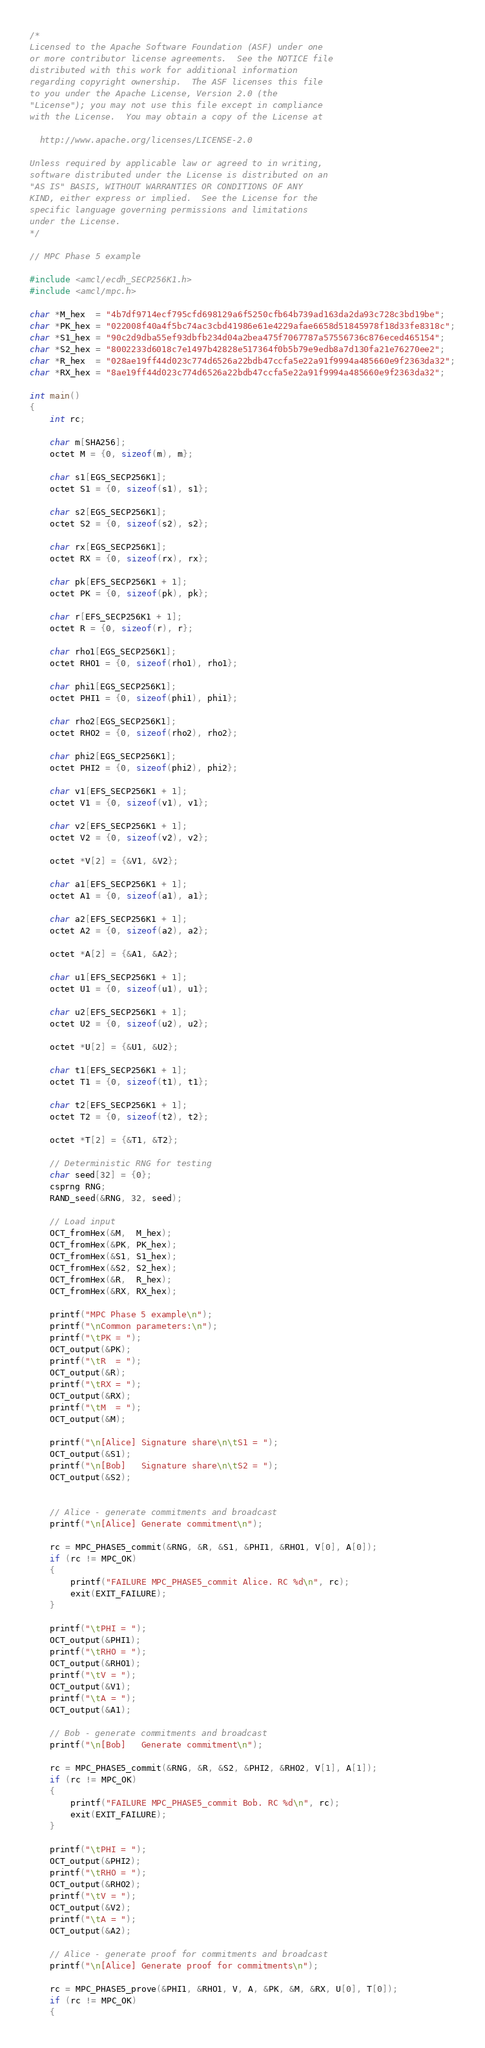<code> <loc_0><loc_0><loc_500><loc_500><_C_>/*
Licensed to the Apache Software Foundation (ASF) under one
or more contributor license agreements.  See the NOTICE file
distributed with this work for additional information
regarding copyright ownership.  The ASF licenses this file
to you under the Apache License, Version 2.0 (the
"License"); you may not use this file except in compliance
with the License.  You may obtain a copy of the License at

  http://www.apache.org/licenses/LICENSE-2.0

Unless required by applicable law or agreed to in writing,
software distributed under the License is distributed on an
"AS IS" BASIS, WITHOUT WARRANTIES OR CONDITIONS OF ANY
KIND, either express or implied.  See the License for the
specific language governing permissions and limitations
under the License.
*/

// MPC Phase 5 example

#include <amcl/ecdh_SECP256K1.h>
#include <amcl/mpc.h>

char *M_hex  = "4b7df9714ecf795cfd698129a6f5250cfb64b739ad163da2da93c728c3bd19be";
char *PK_hex = "022008f40a4f5bc74ac3cbd41986e61e4229afae6658d51845978f18d33fe8318c";
char *S1_hex = "90c2d9dba55ef93dbfb234d04a2bea475f7067787a57556736c876eced465154";
char *S2_hex = "8002233d6018c7e1497b42828e517364f0b5b79e9edb8a7d130fa21e76270ee2";
char *R_hex  = "028ae19ff44d023c774d6526a22bdb47ccfa5e22a91f9994a485660e9f2363da32";
char *RX_hex = "8ae19ff44d023c774d6526a22bdb47ccfa5e22a91f9994a485660e9f2363da32";

int main()
{
    int rc;

    char m[SHA256];
    octet M = {0, sizeof(m), m};

    char s1[EGS_SECP256K1];
    octet S1 = {0, sizeof(s1), s1};

    char s2[EGS_SECP256K1];
    octet S2 = {0, sizeof(s2), s2};

    char rx[EGS_SECP256K1];
    octet RX = {0, sizeof(rx), rx};

    char pk[EFS_SECP256K1 + 1];
    octet PK = {0, sizeof(pk), pk};

    char r[EFS_SECP256K1 + 1];
    octet R = {0, sizeof(r), r};

    char rho1[EGS_SECP256K1];
    octet RHO1 = {0, sizeof(rho1), rho1};

    char phi1[EGS_SECP256K1];
    octet PHI1 = {0, sizeof(phi1), phi1};

    char rho2[EGS_SECP256K1];
    octet RHO2 = {0, sizeof(rho2), rho2};

    char phi2[EGS_SECP256K1];
    octet PHI2 = {0, sizeof(phi2), phi2};

    char v1[EFS_SECP256K1 + 1];
    octet V1 = {0, sizeof(v1), v1};

    char v2[EFS_SECP256K1 + 1];
    octet V2 = {0, sizeof(v2), v2};

    octet *V[2] = {&V1, &V2};

    char a1[EFS_SECP256K1 + 1];
    octet A1 = {0, sizeof(a1), a1};

    char a2[EFS_SECP256K1 + 1];
    octet A2 = {0, sizeof(a2), a2};

    octet *A[2] = {&A1, &A2};

    char u1[EFS_SECP256K1 + 1];
    octet U1 = {0, sizeof(u1), u1};

    char u2[EFS_SECP256K1 + 1];
    octet U2 = {0, sizeof(u2), u2};

    octet *U[2] = {&U1, &U2};

    char t1[EFS_SECP256K1 + 1];
    octet T1 = {0, sizeof(t1), t1};

    char t2[EFS_SECP256K1 + 1];
    octet T2 = {0, sizeof(t2), t2};

    octet *T[2] = {&T1, &T2};

    // Deterministic RNG for testing
    char seed[32] = {0};
    csprng RNG;
    RAND_seed(&RNG, 32, seed);

    // Load input
    OCT_fromHex(&M,  M_hex);
    OCT_fromHex(&PK, PK_hex);
    OCT_fromHex(&S1, S1_hex);
    OCT_fromHex(&S2, S2_hex);
    OCT_fromHex(&R,  R_hex);
    OCT_fromHex(&RX, RX_hex);

    printf("MPC Phase 5 example\n");
    printf("\nCommon parameters:\n");
    printf("\tPK = ");
    OCT_output(&PK);
    printf("\tR  = ");
    OCT_output(&R);
    printf("\tRX = ");
    OCT_output(&RX);
    printf("\tM  = ");
    OCT_output(&M);

    printf("\n[Alice] Signature share\n\tS1 = ");
    OCT_output(&S1);
    printf("\n[Bob]   Signature share\n\tS2 = ");
    OCT_output(&S2);


    // Alice - generate commitments and broadcast
    printf("\n[Alice] Generate commitment\n");

    rc = MPC_PHASE5_commit(&RNG, &R, &S1, &PHI1, &RHO1, V[0], A[0]);
    if (rc != MPC_OK)
    {
        printf("FAILURE MPC_PHASE5_commit Alice. RC %d\n", rc);
        exit(EXIT_FAILURE);
    }

    printf("\tPHI = ");
    OCT_output(&PHI1);
    printf("\tRHO = ");
    OCT_output(&RHO1);
    printf("\tV = ");
    OCT_output(&V1);
    printf("\tA = ");
    OCT_output(&A1);

    // Bob - generate commitments and broadcast
    printf("\n[Bob]   Generate commitment\n");

    rc = MPC_PHASE5_commit(&RNG, &R, &S2, &PHI2, &RHO2, V[1], A[1]);
    if (rc != MPC_OK)
    {
        printf("FAILURE MPC_PHASE5_commit Bob. RC %d\n", rc);
        exit(EXIT_FAILURE);
    }

    printf("\tPHI = ");
    OCT_output(&PHI2);
    printf("\tRHO = ");
    OCT_output(&RHO2);
    printf("\tV = ");
    OCT_output(&V2);
    printf("\tA = ");
    OCT_output(&A2);

    // Alice - generate proof for commitments and broadcast
    printf("\n[Alice] Generate proof for commitments\n");

    rc = MPC_PHASE5_prove(&PHI1, &RHO1, V, A, &PK, &M, &RX, U[0], T[0]);
    if (rc != MPC_OK)
    {</code> 